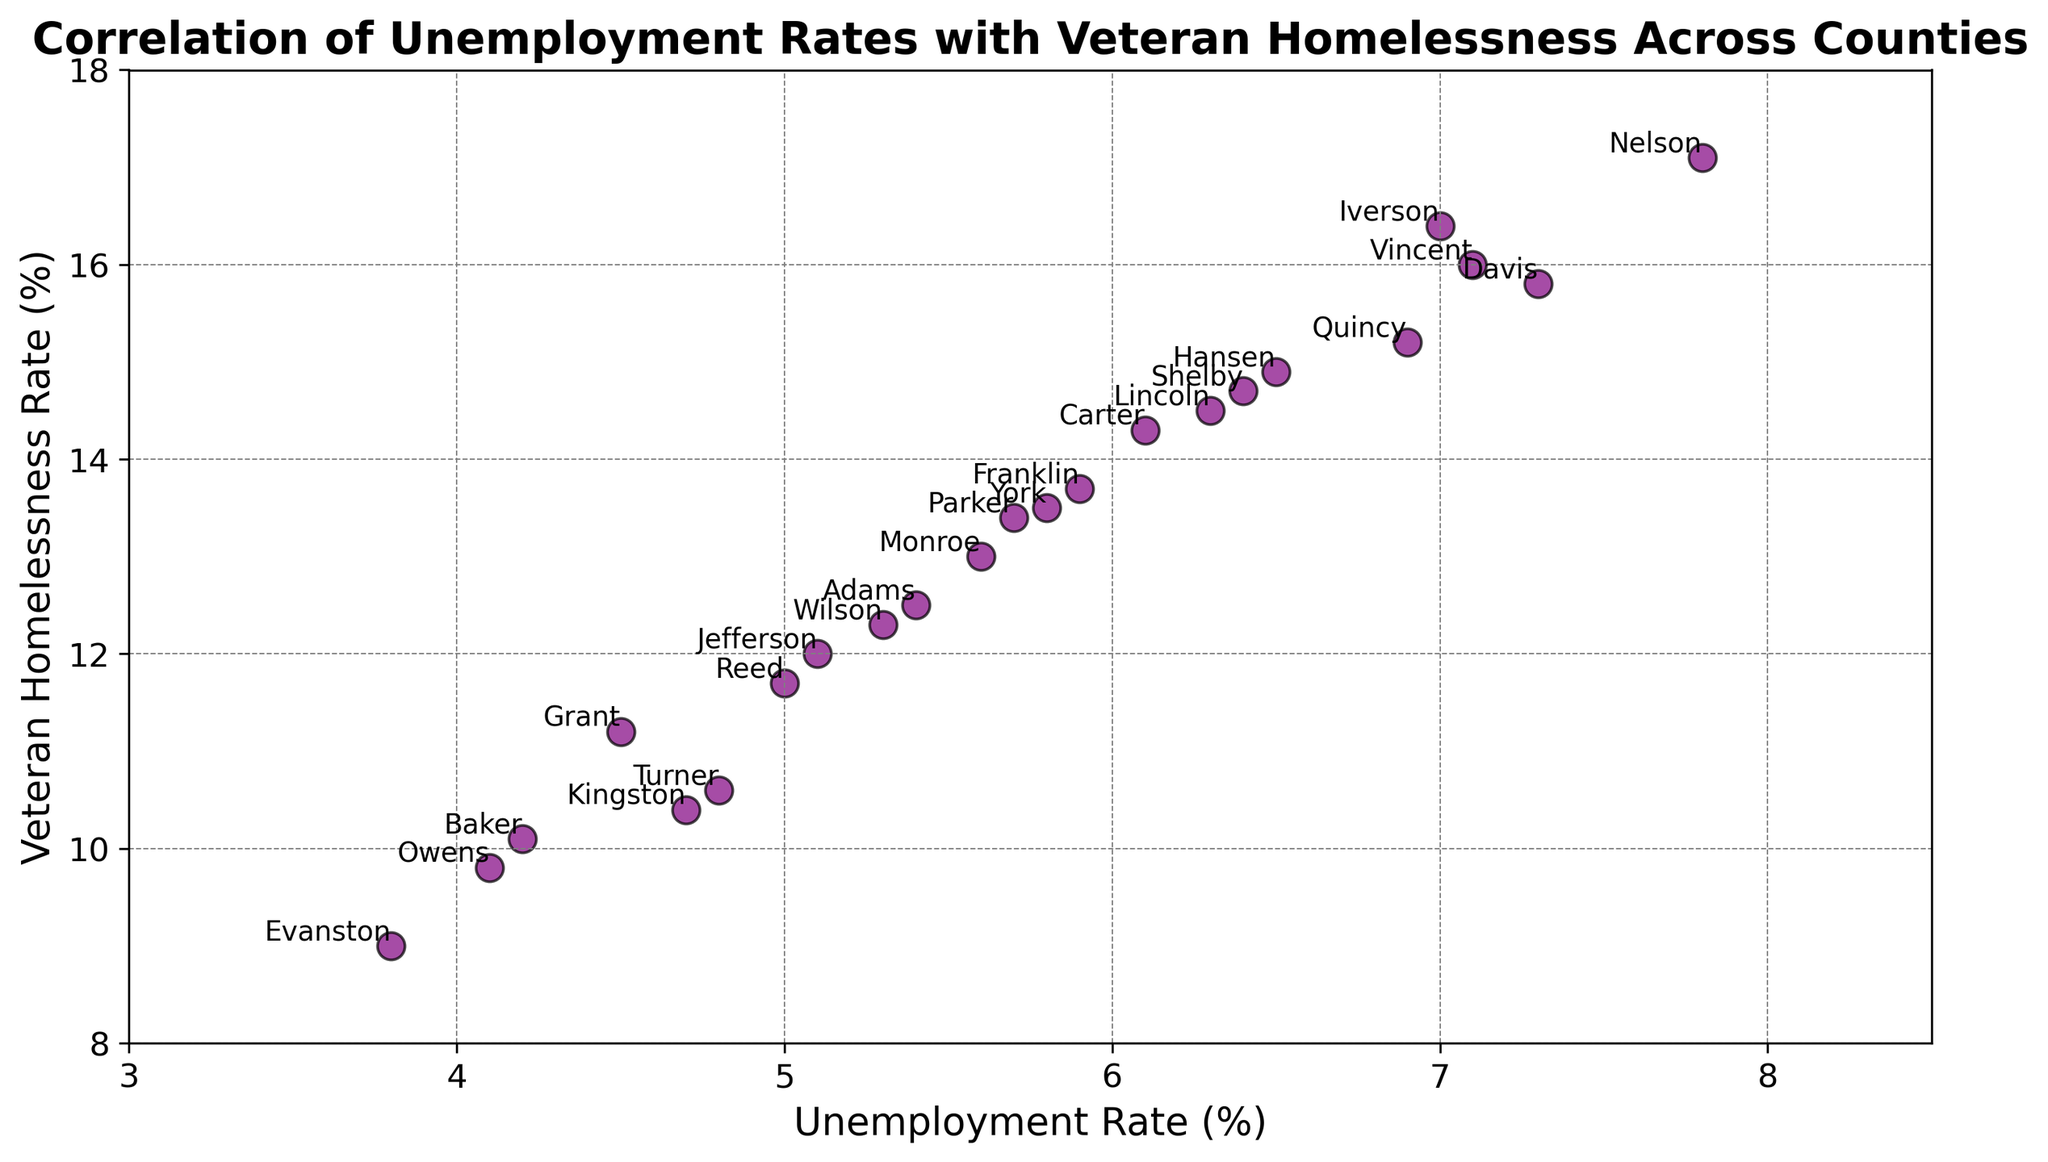Which county has the highest unemployment rate? The scatter plot includes county names annotated near each data point. Searching for the highest value on the x-axis (Unemployment Rate) and checking the corresponding county name provides the answer.
Answer: Nelson Which county has the lowest veteran homelessness rate? Find the data point that is the lowest value on the y-axis (Veteran Homelessness Rate) and identify the county name next to that data point.
Answer: Evanston Is there a visible correlation between unemployment rates and veteran homelessness rates? Observe whether the data points form a pattern or trend on the scatter plot, such as an upward or downward slope. The data points mostly show an upward trend, indicating that as unemployment rates increase, veteran homelessness rates also tend to increase.
Answer: Yes Which counties have both an unemployment rate higher than 6% and veteran homelessness rate higher than 15%? Identify the data points that have x-values (Unemployment Rate) greater than 6% and y-values (Veteran Homelessness Rate) greater than 15%. The counties located at these coordinates are identified by their annotations.
Answer: Davis, Iverson, Nelson, Vincent What is the range of unemployment rates observed across the counties? Identify the lowest and highest values on the x-axis (Unemployment Rate) and calculate the difference between these values. The lowest unemployment rate is 3.8% (Evanston), and the highest is 7.8% (Nelson). Therefore, the range is 7.8% - 3.8%.
Answer: 4.0% How many counties have an unemployment rate less than or equal to 5%? Count the number of data points where the x-axis value (Unemployment Rate) is less than or equal to 5%. The counties that fit this criteria include Baker, Evanston, Grant, Owens, Reed, and Turner.
Answer: 6 What is the average veteran homelessness rate for counties with an unemployment rate greater than 7%? First, identify the counties with unemployment rates greater than 7% (Davis, Iverson, Nelson, Vincent). Then, calculate the average of their veteran homelessness rates: (15.8 + 16.4 + 17.1 + 16.0) / 4.
Answer: 16.3% Which counties have lower veteran homelessness rates than Wilson but higher unemployment rates than York? List the veteran homelessness rates and unemployment rates for Wilson and York: Wilson (12.3%), York (5.8%). Then, analyze all data points that meet both criteria simultaneously.
Answer: None 